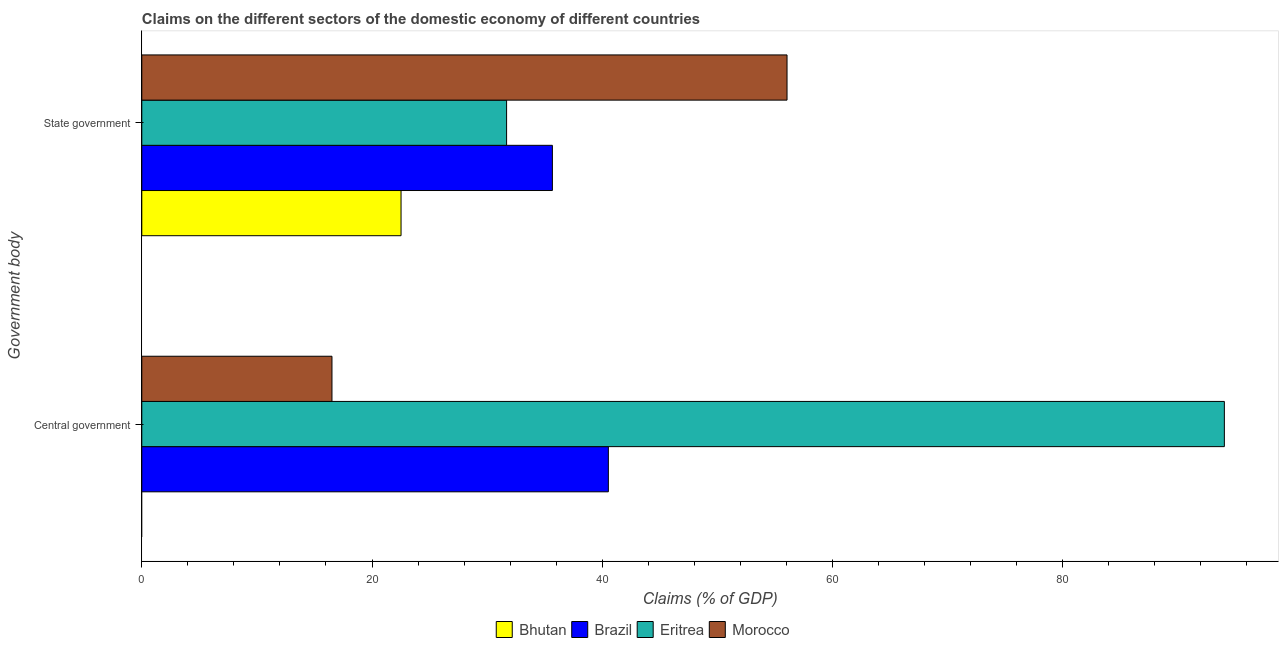Are the number of bars per tick equal to the number of legend labels?
Provide a short and direct response. No. Are the number of bars on each tick of the Y-axis equal?
Provide a succinct answer. No. What is the label of the 2nd group of bars from the top?
Keep it short and to the point. Central government. What is the claims on central government in Eritrea?
Give a very brief answer. 94.04. Across all countries, what is the maximum claims on state government?
Keep it short and to the point. 56.05. Across all countries, what is the minimum claims on state government?
Keep it short and to the point. 22.52. In which country was the claims on state government maximum?
Your answer should be compact. Morocco. What is the total claims on state government in the graph?
Provide a succinct answer. 145.92. What is the difference between the claims on central government in Eritrea and that in Brazil?
Your answer should be compact. 53.51. What is the difference between the claims on central government in Eritrea and the claims on state government in Bhutan?
Ensure brevity in your answer.  71.52. What is the average claims on state government per country?
Your response must be concise. 36.48. What is the difference between the claims on central government and claims on state government in Brazil?
Your answer should be very brief. 4.86. In how many countries, is the claims on state government greater than 8 %?
Your answer should be very brief. 4. What is the ratio of the claims on central government in Brazil to that in Morocco?
Provide a succinct answer. 2.45. Is the claims on central government in Brazil less than that in Eritrea?
Give a very brief answer. Yes. In how many countries, is the claims on central government greater than the average claims on central government taken over all countries?
Ensure brevity in your answer.  2. Are all the bars in the graph horizontal?
Make the answer very short. Yes. How many countries are there in the graph?
Make the answer very short. 4. Are the values on the major ticks of X-axis written in scientific E-notation?
Provide a succinct answer. No. Does the graph contain any zero values?
Your response must be concise. Yes. How many legend labels are there?
Offer a very short reply. 4. What is the title of the graph?
Give a very brief answer. Claims on the different sectors of the domestic economy of different countries. What is the label or title of the X-axis?
Keep it short and to the point. Claims (% of GDP). What is the label or title of the Y-axis?
Your response must be concise. Government body. What is the Claims (% of GDP) in Brazil in Central government?
Make the answer very short. 40.53. What is the Claims (% of GDP) in Eritrea in Central government?
Provide a short and direct response. 94.04. What is the Claims (% of GDP) of Morocco in Central government?
Keep it short and to the point. 16.52. What is the Claims (% of GDP) of Bhutan in State government?
Your answer should be compact. 22.52. What is the Claims (% of GDP) of Brazil in State government?
Ensure brevity in your answer.  35.67. What is the Claims (% of GDP) in Eritrea in State government?
Provide a short and direct response. 31.69. What is the Claims (% of GDP) of Morocco in State government?
Provide a succinct answer. 56.05. Across all Government body, what is the maximum Claims (% of GDP) in Bhutan?
Offer a very short reply. 22.52. Across all Government body, what is the maximum Claims (% of GDP) in Brazil?
Offer a very short reply. 40.53. Across all Government body, what is the maximum Claims (% of GDP) of Eritrea?
Keep it short and to the point. 94.04. Across all Government body, what is the maximum Claims (% of GDP) in Morocco?
Give a very brief answer. 56.05. Across all Government body, what is the minimum Claims (% of GDP) in Bhutan?
Provide a succinct answer. 0. Across all Government body, what is the minimum Claims (% of GDP) in Brazil?
Offer a terse response. 35.67. Across all Government body, what is the minimum Claims (% of GDP) of Eritrea?
Provide a short and direct response. 31.69. Across all Government body, what is the minimum Claims (% of GDP) of Morocco?
Your answer should be compact. 16.52. What is the total Claims (% of GDP) of Bhutan in the graph?
Offer a very short reply. 22.52. What is the total Claims (% of GDP) of Brazil in the graph?
Your answer should be compact. 76.19. What is the total Claims (% of GDP) in Eritrea in the graph?
Your response must be concise. 125.73. What is the total Claims (% of GDP) in Morocco in the graph?
Make the answer very short. 72.57. What is the difference between the Claims (% of GDP) of Brazil in Central government and that in State government?
Offer a terse response. 4.86. What is the difference between the Claims (% of GDP) of Eritrea in Central government and that in State government?
Offer a very short reply. 62.35. What is the difference between the Claims (% of GDP) in Morocco in Central government and that in State government?
Offer a very short reply. -39.53. What is the difference between the Claims (% of GDP) of Brazil in Central government and the Claims (% of GDP) of Eritrea in State government?
Keep it short and to the point. 8.84. What is the difference between the Claims (% of GDP) of Brazil in Central government and the Claims (% of GDP) of Morocco in State government?
Your answer should be compact. -15.52. What is the difference between the Claims (% of GDP) of Eritrea in Central government and the Claims (% of GDP) of Morocco in State government?
Give a very brief answer. 37.99. What is the average Claims (% of GDP) in Bhutan per Government body?
Your answer should be compact. 11.26. What is the average Claims (% of GDP) in Brazil per Government body?
Ensure brevity in your answer.  38.1. What is the average Claims (% of GDP) of Eritrea per Government body?
Give a very brief answer. 62.86. What is the average Claims (% of GDP) of Morocco per Government body?
Your response must be concise. 36.28. What is the difference between the Claims (% of GDP) in Brazil and Claims (% of GDP) in Eritrea in Central government?
Keep it short and to the point. -53.51. What is the difference between the Claims (% of GDP) of Brazil and Claims (% of GDP) of Morocco in Central government?
Provide a succinct answer. 24.01. What is the difference between the Claims (% of GDP) in Eritrea and Claims (% of GDP) in Morocco in Central government?
Your answer should be very brief. 77.52. What is the difference between the Claims (% of GDP) of Bhutan and Claims (% of GDP) of Brazil in State government?
Offer a very short reply. -13.15. What is the difference between the Claims (% of GDP) in Bhutan and Claims (% of GDP) in Eritrea in State government?
Make the answer very short. -9.17. What is the difference between the Claims (% of GDP) in Bhutan and Claims (% of GDP) in Morocco in State government?
Make the answer very short. -33.53. What is the difference between the Claims (% of GDP) of Brazil and Claims (% of GDP) of Eritrea in State government?
Your answer should be compact. 3.98. What is the difference between the Claims (% of GDP) in Brazil and Claims (% of GDP) in Morocco in State government?
Provide a short and direct response. -20.38. What is the difference between the Claims (% of GDP) of Eritrea and Claims (% of GDP) of Morocco in State government?
Offer a very short reply. -24.36. What is the ratio of the Claims (% of GDP) of Brazil in Central government to that in State government?
Provide a succinct answer. 1.14. What is the ratio of the Claims (% of GDP) in Eritrea in Central government to that in State government?
Provide a succinct answer. 2.97. What is the ratio of the Claims (% of GDP) of Morocco in Central government to that in State government?
Give a very brief answer. 0.29. What is the difference between the highest and the second highest Claims (% of GDP) in Brazil?
Your answer should be very brief. 4.86. What is the difference between the highest and the second highest Claims (% of GDP) in Eritrea?
Offer a very short reply. 62.35. What is the difference between the highest and the second highest Claims (% of GDP) in Morocco?
Make the answer very short. 39.53. What is the difference between the highest and the lowest Claims (% of GDP) in Bhutan?
Give a very brief answer. 22.52. What is the difference between the highest and the lowest Claims (% of GDP) in Brazil?
Give a very brief answer. 4.86. What is the difference between the highest and the lowest Claims (% of GDP) in Eritrea?
Offer a terse response. 62.35. What is the difference between the highest and the lowest Claims (% of GDP) in Morocco?
Your answer should be very brief. 39.53. 